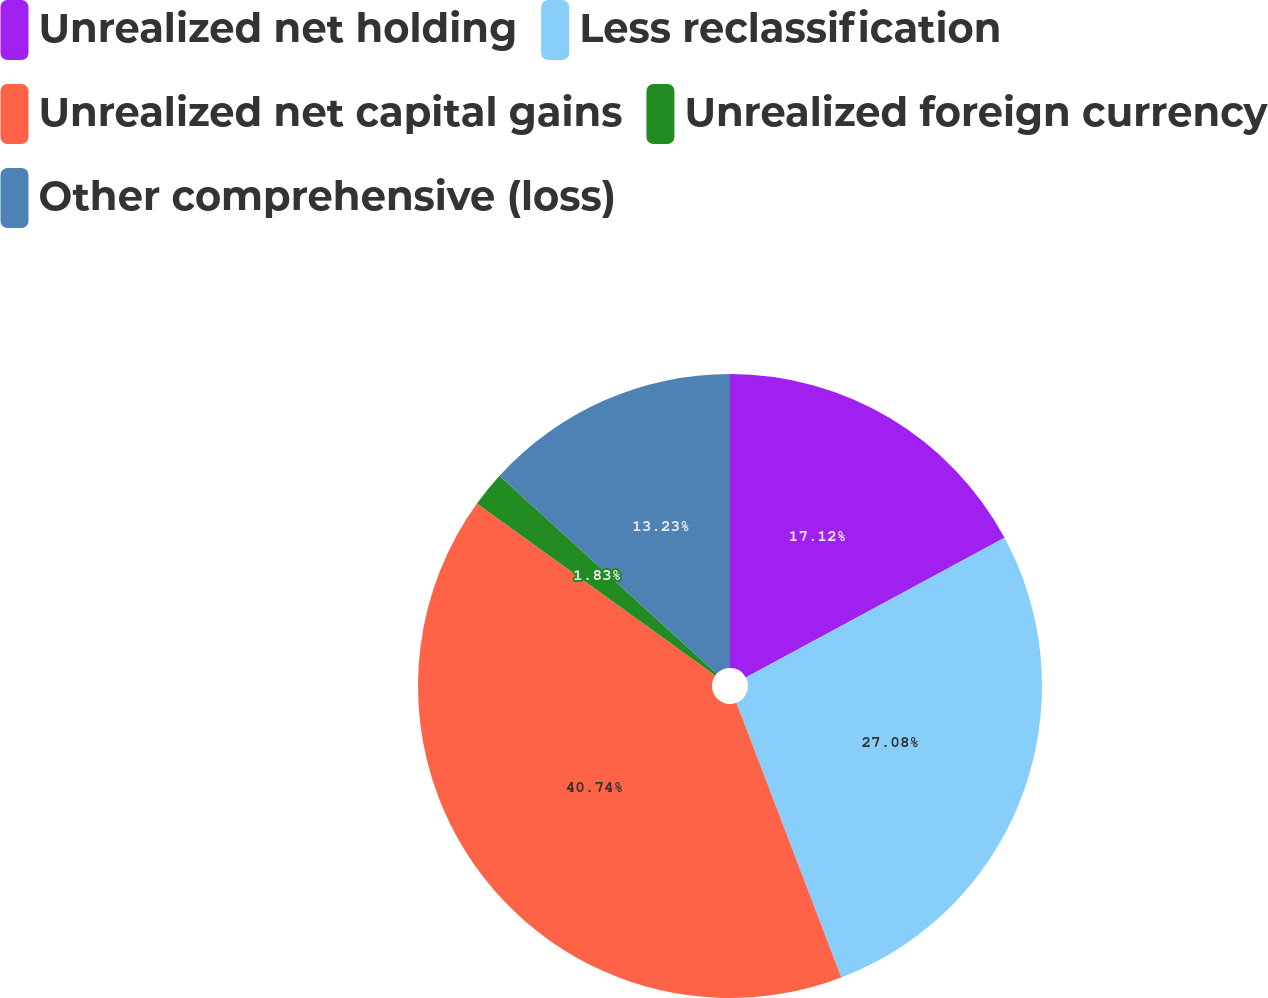<chart> <loc_0><loc_0><loc_500><loc_500><pie_chart><fcel>Unrealized net holding<fcel>Less reclassification<fcel>Unrealized net capital gains<fcel>Unrealized foreign currency<fcel>Other comprehensive (loss)<nl><fcel>17.12%<fcel>27.08%<fcel>40.75%<fcel>1.83%<fcel>13.23%<nl></chart> 